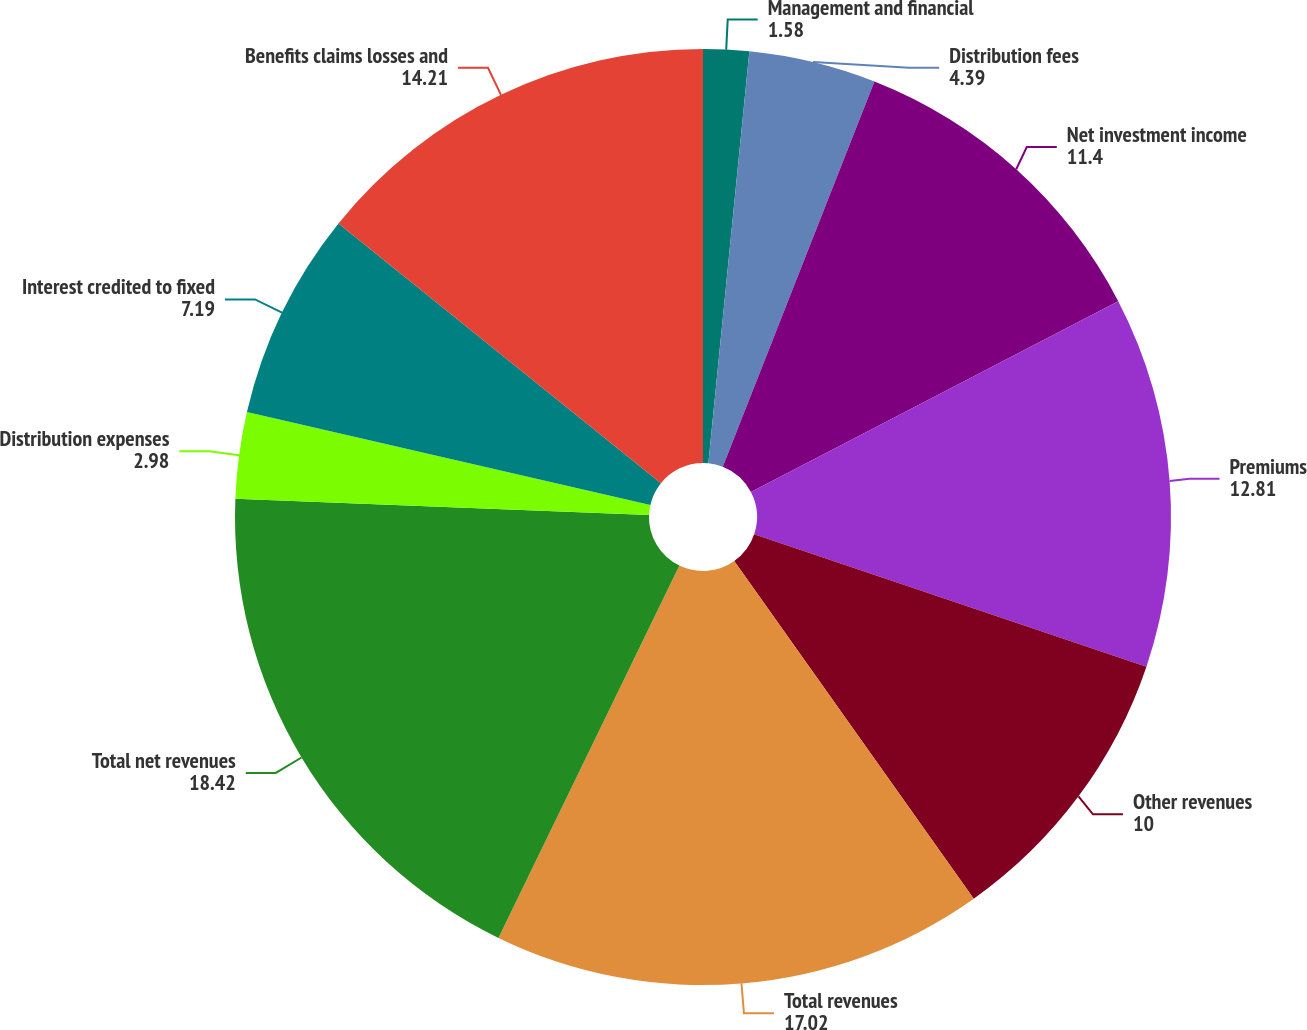<chart> <loc_0><loc_0><loc_500><loc_500><pie_chart><fcel>Management and financial<fcel>Distribution fees<fcel>Net investment income<fcel>Premiums<fcel>Other revenues<fcel>Total revenues<fcel>Total net revenues<fcel>Distribution expenses<fcel>Interest credited to fixed<fcel>Benefits claims losses and<nl><fcel>1.58%<fcel>4.39%<fcel>11.4%<fcel>12.81%<fcel>10.0%<fcel>17.02%<fcel>18.42%<fcel>2.98%<fcel>7.19%<fcel>14.21%<nl></chart> 